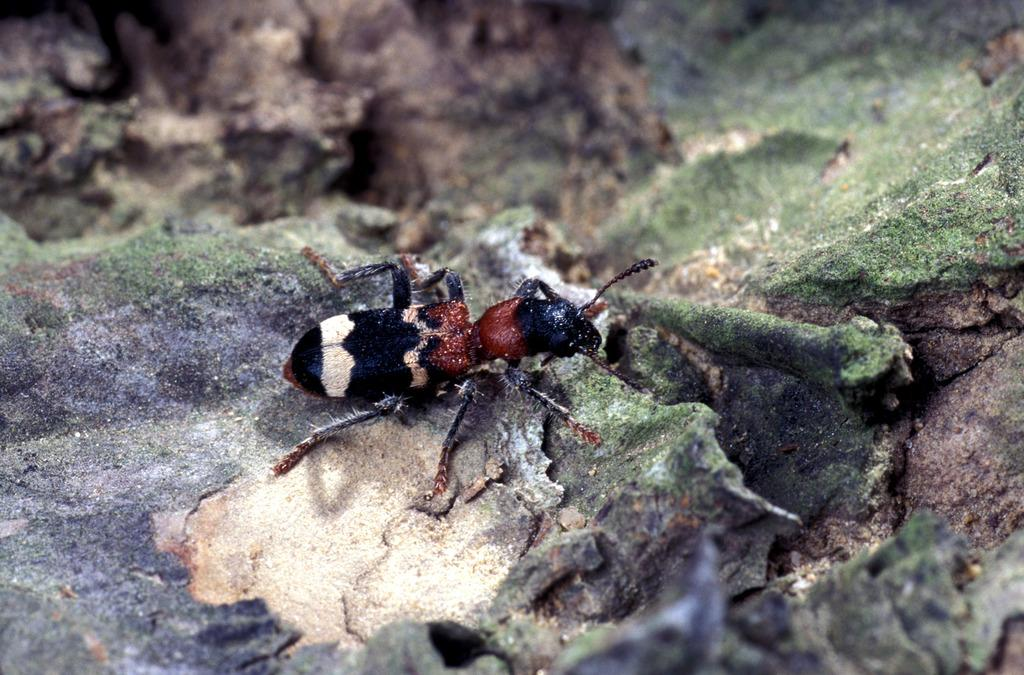What type of objects can be seen in the image? There are stones in the image. Are there any living creatures visible in the image? Yes, there is a bug in the image. What type of liquid can be seen in the image? There is no liquid present in the image; it features stones and a bug. Can you tell me what type of guitar is being played in the image? There is no guitar present in the image. 